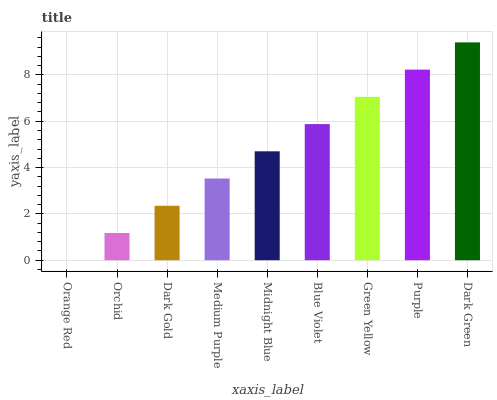Is Orange Red the minimum?
Answer yes or no. Yes. Is Dark Green the maximum?
Answer yes or no. Yes. Is Orchid the minimum?
Answer yes or no. No. Is Orchid the maximum?
Answer yes or no. No. Is Orchid greater than Orange Red?
Answer yes or no. Yes. Is Orange Red less than Orchid?
Answer yes or no. Yes. Is Orange Red greater than Orchid?
Answer yes or no. No. Is Orchid less than Orange Red?
Answer yes or no. No. Is Midnight Blue the high median?
Answer yes or no. Yes. Is Midnight Blue the low median?
Answer yes or no. Yes. Is Purple the high median?
Answer yes or no. No. Is Medium Purple the low median?
Answer yes or no. No. 